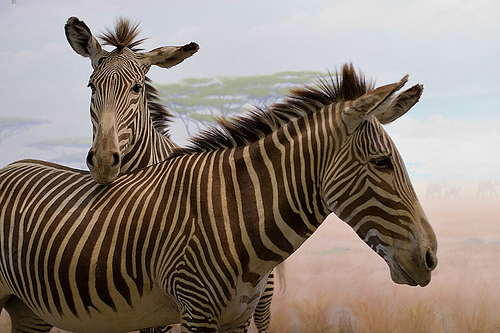Please provide a short description for this region: [0.43, 0.44, 0.65, 0.74]. The region captures the thick neck of a zebra, notable for its robust form and distinctive black and white striping that's typical of the species. 